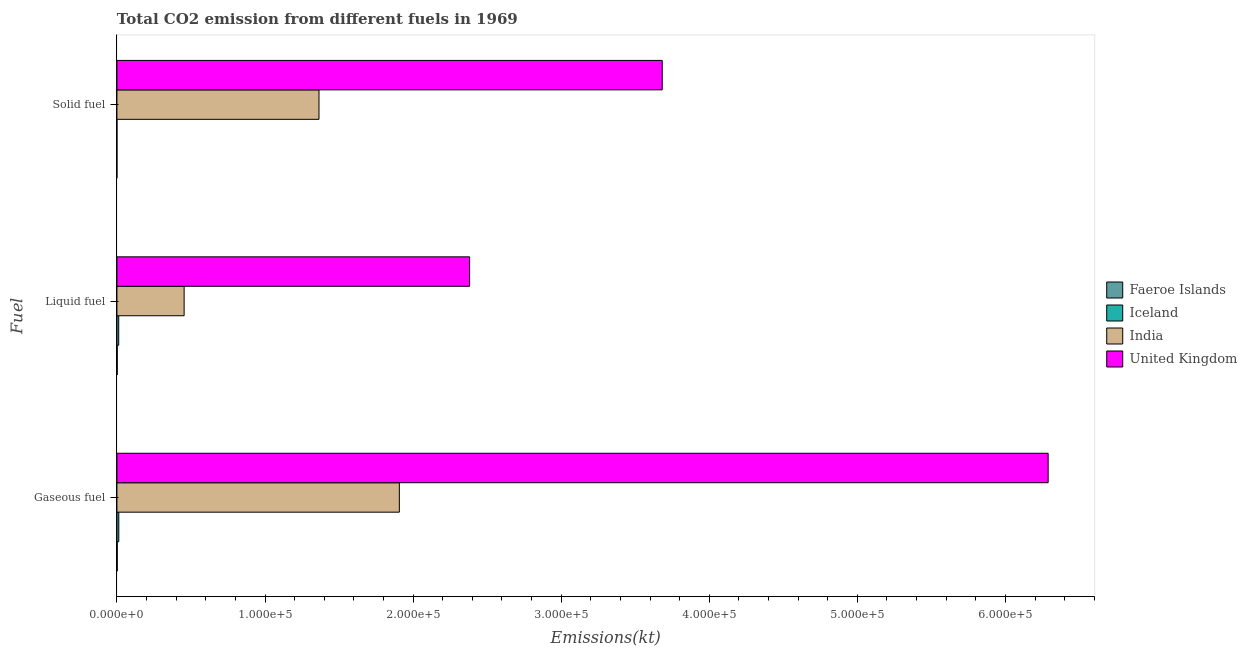How many different coloured bars are there?
Make the answer very short. 4. How many bars are there on the 2nd tick from the top?
Offer a terse response. 4. What is the label of the 2nd group of bars from the top?
Keep it short and to the point. Liquid fuel. What is the amount of co2 emissions from gaseous fuel in Iceland?
Ensure brevity in your answer.  1265.12. Across all countries, what is the maximum amount of co2 emissions from gaseous fuel?
Offer a very short reply. 6.29e+05. Across all countries, what is the minimum amount of co2 emissions from solid fuel?
Offer a terse response. 3.67. In which country was the amount of co2 emissions from liquid fuel maximum?
Offer a very short reply. United Kingdom. In which country was the amount of co2 emissions from solid fuel minimum?
Make the answer very short. Faeroe Islands. What is the total amount of co2 emissions from liquid fuel in the graph?
Keep it short and to the point. 2.85e+05. What is the difference between the amount of co2 emissions from liquid fuel in India and the amount of co2 emissions from solid fuel in Faeroe Islands?
Provide a short and direct response. 4.54e+04. What is the average amount of co2 emissions from solid fuel per country?
Give a very brief answer. 1.26e+05. What is the difference between the amount of co2 emissions from gaseous fuel and amount of co2 emissions from solid fuel in India?
Your answer should be very brief. 5.43e+04. In how many countries, is the amount of co2 emissions from liquid fuel greater than 380000 kt?
Provide a short and direct response. 0. What is the ratio of the amount of co2 emissions from gaseous fuel in Iceland to that in Faeroe Islands?
Your answer should be very brief. 5.95. Is the amount of co2 emissions from gaseous fuel in India less than that in Iceland?
Provide a succinct answer. No. What is the difference between the highest and the second highest amount of co2 emissions from gaseous fuel?
Offer a terse response. 4.38e+05. What is the difference between the highest and the lowest amount of co2 emissions from gaseous fuel?
Your answer should be very brief. 6.29e+05. Is the sum of the amount of co2 emissions from gaseous fuel in United Kingdom and Iceland greater than the maximum amount of co2 emissions from liquid fuel across all countries?
Offer a terse response. Yes. What does the 1st bar from the bottom in Liquid fuel represents?
Give a very brief answer. Faeroe Islands. How many bars are there?
Provide a short and direct response. 12. Are all the bars in the graph horizontal?
Provide a succinct answer. Yes. How many countries are there in the graph?
Make the answer very short. 4. Does the graph contain any zero values?
Your answer should be very brief. No. How many legend labels are there?
Keep it short and to the point. 4. What is the title of the graph?
Give a very brief answer. Total CO2 emission from different fuels in 1969. What is the label or title of the X-axis?
Make the answer very short. Emissions(kt). What is the label or title of the Y-axis?
Ensure brevity in your answer.  Fuel. What is the Emissions(kt) in Faeroe Islands in Gaseous fuel?
Provide a succinct answer. 212.69. What is the Emissions(kt) of Iceland in Gaseous fuel?
Give a very brief answer. 1265.12. What is the Emissions(kt) in India in Gaseous fuel?
Your response must be concise. 1.91e+05. What is the Emissions(kt) in United Kingdom in Gaseous fuel?
Provide a short and direct response. 6.29e+05. What is the Emissions(kt) of Faeroe Islands in Liquid fuel?
Give a very brief answer. 209.02. What is the Emissions(kt) of Iceland in Liquid fuel?
Make the answer very short. 1213.78. What is the Emissions(kt) of India in Liquid fuel?
Your answer should be very brief. 4.54e+04. What is the Emissions(kt) of United Kingdom in Liquid fuel?
Give a very brief answer. 2.38e+05. What is the Emissions(kt) of Faeroe Islands in Solid fuel?
Provide a short and direct response. 3.67. What is the Emissions(kt) of Iceland in Solid fuel?
Offer a terse response. 3.67. What is the Emissions(kt) in India in Solid fuel?
Ensure brevity in your answer.  1.36e+05. What is the Emissions(kt) of United Kingdom in Solid fuel?
Provide a succinct answer. 3.68e+05. Across all Fuel, what is the maximum Emissions(kt) of Faeroe Islands?
Ensure brevity in your answer.  212.69. Across all Fuel, what is the maximum Emissions(kt) of Iceland?
Ensure brevity in your answer.  1265.12. Across all Fuel, what is the maximum Emissions(kt) of India?
Ensure brevity in your answer.  1.91e+05. Across all Fuel, what is the maximum Emissions(kt) of United Kingdom?
Ensure brevity in your answer.  6.29e+05. Across all Fuel, what is the minimum Emissions(kt) of Faeroe Islands?
Ensure brevity in your answer.  3.67. Across all Fuel, what is the minimum Emissions(kt) of Iceland?
Ensure brevity in your answer.  3.67. Across all Fuel, what is the minimum Emissions(kt) of India?
Your answer should be very brief. 4.54e+04. Across all Fuel, what is the minimum Emissions(kt) in United Kingdom?
Your response must be concise. 2.38e+05. What is the total Emissions(kt) of Faeroe Islands in the graph?
Provide a succinct answer. 425.37. What is the total Emissions(kt) in Iceland in the graph?
Provide a succinct answer. 2482.56. What is the total Emissions(kt) of India in the graph?
Provide a short and direct response. 3.73e+05. What is the total Emissions(kt) of United Kingdom in the graph?
Provide a succinct answer. 1.24e+06. What is the difference between the Emissions(kt) of Faeroe Islands in Gaseous fuel and that in Liquid fuel?
Offer a terse response. 3.67. What is the difference between the Emissions(kt) in Iceland in Gaseous fuel and that in Liquid fuel?
Your answer should be very brief. 51.34. What is the difference between the Emissions(kt) in India in Gaseous fuel and that in Liquid fuel?
Your answer should be compact. 1.45e+05. What is the difference between the Emissions(kt) in United Kingdom in Gaseous fuel and that in Liquid fuel?
Give a very brief answer. 3.91e+05. What is the difference between the Emissions(kt) in Faeroe Islands in Gaseous fuel and that in Solid fuel?
Offer a very short reply. 209.02. What is the difference between the Emissions(kt) in Iceland in Gaseous fuel and that in Solid fuel?
Give a very brief answer. 1261.45. What is the difference between the Emissions(kt) in India in Gaseous fuel and that in Solid fuel?
Keep it short and to the point. 5.43e+04. What is the difference between the Emissions(kt) in United Kingdom in Gaseous fuel and that in Solid fuel?
Ensure brevity in your answer.  2.61e+05. What is the difference between the Emissions(kt) of Faeroe Islands in Liquid fuel and that in Solid fuel?
Provide a succinct answer. 205.35. What is the difference between the Emissions(kt) of Iceland in Liquid fuel and that in Solid fuel?
Offer a terse response. 1210.11. What is the difference between the Emissions(kt) in India in Liquid fuel and that in Solid fuel?
Your answer should be very brief. -9.11e+04. What is the difference between the Emissions(kt) in United Kingdom in Liquid fuel and that in Solid fuel?
Provide a short and direct response. -1.30e+05. What is the difference between the Emissions(kt) of Faeroe Islands in Gaseous fuel and the Emissions(kt) of Iceland in Liquid fuel?
Keep it short and to the point. -1001.09. What is the difference between the Emissions(kt) of Faeroe Islands in Gaseous fuel and the Emissions(kt) of India in Liquid fuel?
Keep it short and to the point. -4.52e+04. What is the difference between the Emissions(kt) in Faeroe Islands in Gaseous fuel and the Emissions(kt) in United Kingdom in Liquid fuel?
Ensure brevity in your answer.  -2.38e+05. What is the difference between the Emissions(kt) of Iceland in Gaseous fuel and the Emissions(kt) of India in Liquid fuel?
Keep it short and to the point. -4.41e+04. What is the difference between the Emissions(kt) in Iceland in Gaseous fuel and the Emissions(kt) in United Kingdom in Liquid fuel?
Offer a very short reply. -2.37e+05. What is the difference between the Emissions(kt) of India in Gaseous fuel and the Emissions(kt) of United Kingdom in Liquid fuel?
Give a very brief answer. -4.75e+04. What is the difference between the Emissions(kt) in Faeroe Islands in Gaseous fuel and the Emissions(kt) in Iceland in Solid fuel?
Ensure brevity in your answer.  209.02. What is the difference between the Emissions(kt) of Faeroe Islands in Gaseous fuel and the Emissions(kt) of India in Solid fuel?
Provide a short and direct response. -1.36e+05. What is the difference between the Emissions(kt) in Faeroe Islands in Gaseous fuel and the Emissions(kt) in United Kingdom in Solid fuel?
Make the answer very short. -3.68e+05. What is the difference between the Emissions(kt) in Iceland in Gaseous fuel and the Emissions(kt) in India in Solid fuel?
Ensure brevity in your answer.  -1.35e+05. What is the difference between the Emissions(kt) in Iceland in Gaseous fuel and the Emissions(kt) in United Kingdom in Solid fuel?
Your answer should be compact. -3.67e+05. What is the difference between the Emissions(kt) of India in Gaseous fuel and the Emissions(kt) of United Kingdom in Solid fuel?
Provide a succinct answer. -1.78e+05. What is the difference between the Emissions(kt) of Faeroe Islands in Liquid fuel and the Emissions(kt) of Iceland in Solid fuel?
Your answer should be very brief. 205.35. What is the difference between the Emissions(kt) in Faeroe Islands in Liquid fuel and the Emissions(kt) in India in Solid fuel?
Ensure brevity in your answer.  -1.36e+05. What is the difference between the Emissions(kt) of Faeroe Islands in Liquid fuel and the Emissions(kt) of United Kingdom in Solid fuel?
Offer a terse response. -3.68e+05. What is the difference between the Emissions(kt) of Iceland in Liquid fuel and the Emissions(kt) of India in Solid fuel?
Your answer should be compact. -1.35e+05. What is the difference between the Emissions(kt) of Iceland in Liquid fuel and the Emissions(kt) of United Kingdom in Solid fuel?
Offer a terse response. -3.67e+05. What is the difference between the Emissions(kt) in India in Liquid fuel and the Emissions(kt) in United Kingdom in Solid fuel?
Provide a succinct answer. -3.23e+05. What is the average Emissions(kt) of Faeroe Islands per Fuel?
Give a very brief answer. 141.79. What is the average Emissions(kt) in Iceland per Fuel?
Your response must be concise. 827.52. What is the average Emissions(kt) of India per Fuel?
Offer a very short reply. 1.24e+05. What is the average Emissions(kt) in United Kingdom per Fuel?
Provide a short and direct response. 4.12e+05. What is the difference between the Emissions(kt) in Faeroe Islands and Emissions(kt) in Iceland in Gaseous fuel?
Your answer should be compact. -1052.43. What is the difference between the Emissions(kt) in Faeroe Islands and Emissions(kt) in India in Gaseous fuel?
Ensure brevity in your answer.  -1.91e+05. What is the difference between the Emissions(kt) of Faeroe Islands and Emissions(kt) of United Kingdom in Gaseous fuel?
Ensure brevity in your answer.  -6.29e+05. What is the difference between the Emissions(kt) in Iceland and Emissions(kt) in India in Gaseous fuel?
Your answer should be very brief. -1.89e+05. What is the difference between the Emissions(kt) in Iceland and Emissions(kt) in United Kingdom in Gaseous fuel?
Ensure brevity in your answer.  -6.28e+05. What is the difference between the Emissions(kt) of India and Emissions(kt) of United Kingdom in Gaseous fuel?
Your response must be concise. -4.38e+05. What is the difference between the Emissions(kt) of Faeroe Islands and Emissions(kt) of Iceland in Liquid fuel?
Offer a very short reply. -1004.76. What is the difference between the Emissions(kt) in Faeroe Islands and Emissions(kt) in India in Liquid fuel?
Keep it short and to the point. -4.52e+04. What is the difference between the Emissions(kt) of Faeroe Islands and Emissions(kt) of United Kingdom in Liquid fuel?
Give a very brief answer. -2.38e+05. What is the difference between the Emissions(kt) of Iceland and Emissions(kt) of India in Liquid fuel?
Provide a short and direct response. -4.42e+04. What is the difference between the Emissions(kt) in Iceland and Emissions(kt) in United Kingdom in Liquid fuel?
Make the answer very short. -2.37e+05. What is the difference between the Emissions(kt) in India and Emissions(kt) in United Kingdom in Liquid fuel?
Make the answer very short. -1.93e+05. What is the difference between the Emissions(kt) of Faeroe Islands and Emissions(kt) of Iceland in Solid fuel?
Provide a short and direct response. 0. What is the difference between the Emissions(kt) in Faeroe Islands and Emissions(kt) in India in Solid fuel?
Make the answer very short. -1.36e+05. What is the difference between the Emissions(kt) of Faeroe Islands and Emissions(kt) of United Kingdom in Solid fuel?
Your answer should be compact. -3.68e+05. What is the difference between the Emissions(kt) of Iceland and Emissions(kt) of India in Solid fuel?
Ensure brevity in your answer.  -1.36e+05. What is the difference between the Emissions(kt) of Iceland and Emissions(kt) of United Kingdom in Solid fuel?
Offer a very short reply. -3.68e+05. What is the difference between the Emissions(kt) in India and Emissions(kt) in United Kingdom in Solid fuel?
Provide a succinct answer. -2.32e+05. What is the ratio of the Emissions(kt) in Faeroe Islands in Gaseous fuel to that in Liquid fuel?
Make the answer very short. 1.02. What is the ratio of the Emissions(kt) in Iceland in Gaseous fuel to that in Liquid fuel?
Your response must be concise. 1.04. What is the ratio of the Emissions(kt) in India in Gaseous fuel to that in Liquid fuel?
Give a very brief answer. 4.2. What is the ratio of the Emissions(kt) of United Kingdom in Gaseous fuel to that in Liquid fuel?
Ensure brevity in your answer.  2.64. What is the ratio of the Emissions(kt) in Iceland in Gaseous fuel to that in Solid fuel?
Offer a terse response. 345. What is the ratio of the Emissions(kt) of India in Gaseous fuel to that in Solid fuel?
Offer a very short reply. 1.4. What is the ratio of the Emissions(kt) of United Kingdom in Gaseous fuel to that in Solid fuel?
Your response must be concise. 1.71. What is the ratio of the Emissions(kt) in Iceland in Liquid fuel to that in Solid fuel?
Your answer should be very brief. 331. What is the ratio of the Emissions(kt) of India in Liquid fuel to that in Solid fuel?
Ensure brevity in your answer.  0.33. What is the ratio of the Emissions(kt) in United Kingdom in Liquid fuel to that in Solid fuel?
Your response must be concise. 0.65. What is the difference between the highest and the second highest Emissions(kt) of Faeroe Islands?
Offer a terse response. 3.67. What is the difference between the highest and the second highest Emissions(kt) in Iceland?
Offer a terse response. 51.34. What is the difference between the highest and the second highest Emissions(kt) in India?
Your answer should be compact. 5.43e+04. What is the difference between the highest and the second highest Emissions(kt) in United Kingdom?
Your answer should be very brief. 2.61e+05. What is the difference between the highest and the lowest Emissions(kt) in Faeroe Islands?
Give a very brief answer. 209.02. What is the difference between the highest and the lowest Emissions(kt) in Iceland?
Offer a very short reply. 1261.45. What is the difference between the highest and the lowest Emissions(kt) of India?
Make the answer very short. 1.45e+05. What is the difference between the highest and the lowest Emissions(kt) in United Kingdom?
Your response must be concise. 3.91e+05. 